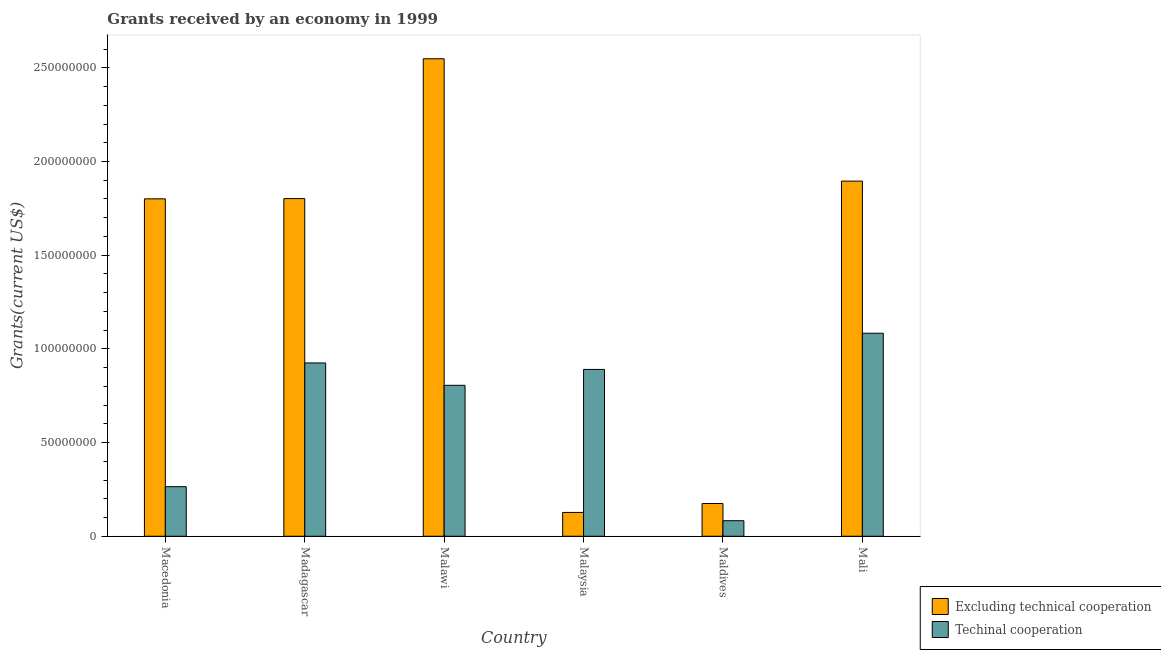How many groups of bars are there?
Your response must be concise. 6. Are the number of bars on each tick of the X-axis equal?
Your response must be concise. Yes. How many bars are there on the 6th tick from the left?
Provide a succinct answer. 2. What is the label of the 1st group of bars from the left?
Offer a terse response. Macedonia. In how many cases, is the number of bars for a given country not equal to the number of legend labels?
Provide a short and direct response. 0. What is the amount of grants received(including technical cooperation) in Malaysia?
Ensure brevity in your answer.  8.90e+07. Across all countries, what is the maximum amount of grants received(including technical cooperation)?
Offer a very short reply. 1.08e+08. Across all countries, what is the minimum amount of grants received(including technical cooperation)?
Give a very brief answer. 8.29e+06. In which country was the amount of grants received(excluding technical cooperation) maximum?
Keep it short and to the point. Malawi. In which country was the amount of grants received(excluding technical cooperation) minimum?
Make the answer very short. Malaysia. What is the total amount of grants received(excluding technical cooperation) in the graph?
Offer a very short reply. 8.35e+08. What is the difference between the amount of grants received(excluding technical cooperation) in Macedonia and that in Mali?
Provide a short and direct response. -9.45e+06. What is the difference between the amount of grants received(excluding technical cooperation) in Maldives and the amount of grants received(including technical cooperation) in Madagascar?
Offer a terse response. -7.50e+07. What is the average amount of grants received(excluding technical cooperation) per country?
Keep it short and to the point. 1.39e+08. What is the difference between the amount of grants received(excluding technical cooperation) and amount of grants received(including technical cooperation) in Mali?
Your answer should be very brief. 8.12e+07. What is the ratio of the amount of grants received(excluding technical cooperation) in Malawi to that in Maldives?
Keep it short and to the point. 14.59. Is the amount of grants received(excluding technical cooperation) in Madagascar less than that in Mali?
Your response must be concise. Yes. Is the difference between the amount of grants received(including technical cooperation) in Macedonia and Malawi greater than the difference between the amount of grants received(excluding technical cooperation) in Macedonia and Malawi?
Your answer should be very brief. Yes. What is the difference between the highest and the second highest amount of grants received(including technical cooperation)?
Make the answer very short. 1.59e+07. What is the difference between the highest and the lowest amount of grants received(excluding technical cooperation)?
Provide a short and direct response. 2.42e+08. In how many countries, is the amount of grants received(including technical cooperation) greater than the average amount of grants received(including technical cooperation) taken over all countries?
Give a very brief answer. 4. What does the 2nd bar from the left in Macedonia represents?
Make the answer very short. Techinal cooperation. What does the 1st bar from the right in Maldives represents?
Your answer should be compact. Techinal cooperation. How many bars are there?
Offer a very short reply. 12. What is the difference between two consecutive major ticks on the Y-axis?
Make the answer very short. 5.00e+07. Are the values on the major ticks of Y-axis written in scientific E-notation?
Keep it short and to the point. No. Where does the legend appear in the graph?
Offer a terse response. Bottom right. How many legend labels are there?
Make the answer very short. 2. How are the legend labels stacked?
Provide a succinct answer. Vertical. What is the title of the graph?
Offer a very short reply. Grants received by an economy in 1999. What is the label or title of the X-axis?
Make the answer very short. Country. What is the label or title of the Y-axis?
Your answer should be compact. Grants(current US$). What is the Grants(current US$) in Excluding technical cooperation in Macedonia?
Give a very brief answer. 1.80e+08. What is the Grants(current US$) of Techinal cooperation in Macedonia?
Provide a short and direct response. 2.64e+07. What is the Grants(current US$) of Excluding technical cooperation in Madagascar?
Make the answer very short. 1.80e+08. What is the Grants(current US$) in Techinal cooperation in Madagascar?
Provide a succinct answer. 9.25e+07. What is the Grants(current US$) of Excluding technical cooperation in Malawi?
Your response must be concise. 2.55e+08. What is the Grants(current US$) of Techinal cooperation in Malawi?
Offer a terse response. 8.06e+07. What is the Grants(current US$) in Excluding technical cooperation in Malaysia?
Your answer should be very brief. 1.27e+07. What is the Grants(current US$) in Techinal cooperation in Malaysia?
Provide a short and direct response. 8.90e+07. What is the Grants(current US$) of Excluding technical cooperation in Maldives?
Your response must be concise. 1.75e+07. What is the Grants(current US$) in Techinal cooperation in Maldives?
Your answer should be very brief. 8.29e+06. What is the Grants(current US$) in Excluding technical cooperation in Mali?
Keep it short and to the point. 1.90e+08. What is the Grants(current US$) in Techinal cooperation in Mali?
Offer a terse response. 1.08e+08. Across all countries, what is the maximum Grants(current US$) in Excluding technical cooperation?
Give a very brief answer. 2.55e+08. Across all countries, what is the maximum Grants(current US$) of Techinal cooperation?
Provide a short and direct response. 1.08e+08. Across all countries, what is the minimum Grants(current US$) of Excluding technical cooperation?
Offer a terse response. 1.27e+07. Across all countries, what is the minimum Grants(current US$) of Techinal cooperation?
Your answer should be compact. 8.29e+06. What is the total Grants(current US$) in Excluding technical cooperation in the graph?
Your response must be concise. 8.35e+08. What is the total Grants(current US$) in Techinal cooperation in the graph?
Ensure brevity in your answer.  4.05e+08. What is the difference between the Grants(current US$) in Excluding technical cooperation in Macedonia and that in Madagascar?
Offer a very short reply. -1.20e+05. What is the difference between the Grants(current US$) of Techinal cooperation in Macedonia and that in Madagascar?
Provide a short and direct response. -6.60e+07. What is the difference between the Grants(current US$) of Excluding technical cooperation in Macedonia and that in Malawi?
Provide a short and direct response. -7.48e+07. What is the difference between the Grants(current US$) of Techinal cooperation in Macedonia and that in Malawi?
Your answer should be very brief. -5.41e+07. What is the difference between the Grants(current US$) of Excluding technical cooperation in Macedonia and that in Malaysia?
Provide a succinct answer. 1.67e+08. What is the difference between the Grants(current US$) in Techinal cooperation in Macedonia and that in Malaysia?
Give a very brief answer. -6.26e+07. What is the difference between the Grants(current US$) of Excluding technical cooperation in Macedonia and that in Maldives?
Your response must be concise. 1.63e+08. What is the difference between the Grants(current US$) of Techinal cooperation in Macedonia and that in Maldives?
Your answer should be very brief. 1.82e+07. What is the difference between the Grants(current US$) in Excluding technical cooperation in Macedonia and that in Mali?
Ensure brevity in your answer.  -9.45e+06. What is the difference between the Grants(current US$) of Techinal cooperation in Macedonia and that in Mali?
Give a very brief answer. -8.19e+07. What is the difference between the Grants(current US$) in Excluding technical cooperation in Madagascar and that in Malawi?
Make the answer very short. -7.46e+07. What is the difference between the Grants(current US$) of Techinal cooperation in Madagascar and that in Malawi?
Your answer should be compact. 1.19e+07. What is the difference between the Grants(current US$) of Excluding technical cooperation in Madagascar and that in Malaysia?
Offer a terse response. 1.67e+08. What is the difference between the Grants(current US$) of Techinal cooperation in Madagascar and that in Malaysia?
Give a very brief answer. 3.46e+06. What is the difference between the Grants(current US$) of Excluding technical cooperation in Madagascar and that in Maldives?
Offer a very short reply. 1.63e+08. What is the difference between the Grants(current US$) of Techinal cooperation in Madagascar and that in Maldives?
Make the answer very short. 8.42e+07. What is the difference between the Grants(current US$) in Excluding technical cooperation in Madagascar and that in Mali?
Your answer should be very brief. -9.33e+06. What is the difference between the Grants(current US$) in Techinal cooperation in Madagascar and that in Mali?
Your response must be concise. -1.59e+07. What is the difference between the Grants(current US$) of Excluding technical cooperation in Malawi and that in Malaysia?
Your answer should be compact. 2.42e+08. What is the difference between the Grants(current US$) of Techinal cooperation in Malawi and that in Malaysia?
Provide a succinct answer. -8.47e+06. What is the difference between the Grants(current US$) of Excluding technical cooperation in Malawi and that in Maldives?
Make the answer very short. 2.37e+08. What is the difference between the Grants(current US$) of Techinal cooperation in Malawi and that in Maldives?
Offer a very short reply. 7.23e+07. What is the difference between the Grants(current US$) of Excluding technical cooperation in Malawi and that in Mali?
Offer a very short reply. 6.53e+07. What is the difference between the Grants(current US$) in Techinal cooperation in Malawi and that in Mali?
Offer a very short reply. -2.78e+07. What is the difference between the Grants(current US$) of Excluding technical cooperation in Malaysia and that in Maldives?
Your answer should be very brief. -4.76e+06. What is the difference between the Grants(current US$) in Techinal cooperation in Malaysia and that in Maldives?
Keep it short and to the point. 8.07e+07. What is the difference between the Grants(current US$) in Excluding technical cooperation in Malaysia and that in Mali?
Keep it short and to the point. -1.77e+08. What is the difference between the Grants(current US$) of Techinal cooperation in Malaysia and that in Mali?
Ensure brevity in your answer.  -1.93e+07. What is the difference between the Grants(current US$) of Excluding technical cooperation in Maldives and that in Mali?
Provide a short and direct response. -1.72e+08. What is the difference between the Grants(current US$) in Techinal cooperation in Maldives and that in Mali?
Offer a terse response. -1.00e+08. What is the difference between the Grants(current US$) in Excluding technical cooperation in Macedonia and the Grants(current US$) in Techinal cooperation in Madagascar?
Your answer should be very brief. 8.76e+07. What is the difference between the Grants(current US$) of Excluding technical cooperation in Macedonia and the Grants(current US$) of Techinal cooperation in Malawi?
Offer a terse response. 9.95e+07. What is the difference between the Grants(current US$) in Excluding technical cooperation in Macedonia and the Grants(current US$) in Techinal cooperation in Malaysia?
Keep it short and to the point. 9.10e+07. What is the difference between the Grants(current US$) of Excluding technical cooperation in Macedonia and the Grants(current US$) of Techinal cooperation in Maldives?
Provide a short and direct response. 1.72e+08. What is the difference between the Grants(current US$) in Excluding technical cooperation in Macedonia and the Grants(current US$) in Techinal cooperation in Mali?
Offer a very short reply. 7.17e+07. What is the difference between the Grants(current US$) of Excluding technical cooperation in Madagascar and the Grants(current US$) of Techinal cooperation in Malawi?
Make the answer very short. 9.96e+07. What is the difference between the Grants(current US$) of Excluding technical cooperation in Madagascar and the Grants(current US$) of Techinal cooperation in Malaysia?
Provide a succinct answer. 9.12e+07. What is the difference between the Grants(current US$) in Excluding technical cooperation in Madagascar and the Grants(current US$) in Techinal cooperation in Maldives?
Your answer should be very brief. 1.72e+08. What is the difference between the Grants(current US$) of Excluding technical cooperation in Madagascar and the Grants(current US$) of Techinal cooperation in Mali?
Give a very brief answer. 7.18e+07. What is the difference between the Grants(current US$) of Excluding technical cooperation in Malawi and the Grants(current US$) of Techinal cooperation in Malaysia?
Offer a terse response. 1.66e+08. What is the difference between the Grants(current US$) of Excluding technical cooperation in Malawi and the Grants(current US$) of Techinal cooperation in Maldives?
Ensure brevity in your answer.  2.47e+08. What is the difference between the Grants(current US$) of Excluding technical cooperation in Malawi and the Grants(current US$) of Techinal cooperation in Mali?
Ensure brevity in your answer.  1.46e+08. What is the difference between the Grants(current US$) in Excluding technical cooperation in Malaysia and the Grants(current US$) in Techinal cooperation in Maldives?
Provide a short and direct response. 4.42e+06. What is the difference between the Grants(current US$) in Excluding technical cooperation in Malaysia and the Grants(current US$) in Techinal cooperation in Mali?
Give a very brief answer. -9.56e+07. What is the difference between the Grants(current US$) of Excluding technical cooperation in Maldives and the Grants(current US$) of Techinal cooperation in Mali?
Make the answer very short. -9.09e+07. What is the average Grants(current US$) in Excluding technical cooperation per country?
Your answer should be very brief. 1.39e+08. What is the average Grants(current US$) of Techinal cooperation per country?
Provide a succinct answer. 6.75e+07. What is the difference between the Grants(current US$) of Excluding technical cooperation and Grants(current US$) of Techinal cooperation in Macedonia?
Give a very brief answer. 1.54e+08. What is the difference between the Grants(current US$) of Excluding technical cooperation and Grants(current US$) of Techinal cooperation in Madagascar?
Ensure brevity in your answer.  8.77e+07. What is the difference between the Grants(current US$) of Excluding technical cooperation and Grants(current US$) of Techinal cooperation in Malawi?
Your response must be concise. 1.74e+08. What is the difference between the Grants(current US$) of Excluding technical cooperation and Grants(current US$) of Techinal cooperation in Malaysia?
Your answer should be compact. -7.63e+07. What is the difference between the Grants(current US$) in Excluding technical cooperation and Grants(current US$) in Techinal cooperation in Maldives?
Provide a short and direct response. 9.18e+06. What is the difference between the Grants(current US$) of Excluding technical cooperation and Grants(current US$) of Techinal cooperation in Mali?
Provide a short and direct response. 8.12e+07. What is the ratio of the Grants(current US$) in Techinal cooperation in Macedonia to that in Madagascar?
Provide a succinct answer. 0.29. What is the ratio of the Grants(current US$) of Excluding technical cooperation in Macedonia to that in Malawi?
Offer a terse response. 0.71. What is the ratio of the Grants(current US$) in Techinal cooperation in Macedonia to that in Malawi?
Give a very brief answer. 0.33. What is the ratio of the Grants(current US$) in Excluding technical cooperation in Macedonia to that in Malaysia?
Keep it short and to the point. 14.17. What is the ratio of the Grants(current US$) of Techinal cooperation in Macedonia to that in Malaysia?
Make the answer very short. 0.3. What is the ratio of the Grants(current US$) of Excluding technical cooperation in Macedonia to that in Maldives?
Offer a very short reply. 10.31. What is the ratio of the Grants(current US$) of Techinal cooperation in Macedonia to that in Maldives?
Ensure brevity in your answer.  3.19. What is the ratio of the Grants(current US$) of Excluding technical cooperation in Macedonia to that in Mali?
Offer a terse response. 0.95. What is the ratio of the Grants(current US$) of Techinal cooperation in Macedonia to that in Mali?
Ensure brevity in your answer.  0.24. What is the ratio of the Grants(current US$) of Excluding technical cooperation in Madagascar to that in Malawi?
Keep it short and to the point. 0.71. What is the ratio of the Grants(current US$) in Techinal cooperation in Madagascar to that in Malawi?
Give a very brief answer. 1.15. What is the ratio of the Grants(current US$) of Excluding technical cooperation in Madagascar to that in Malaysia?
Offer a very short reply. 14.18. What is the ratio of the Grants(current US$) in Techinal cooperation in Madagascar to that in Malaysia?
Your answer should be very brief. 1.04. What is the ratio of the Grants(current US$) of Excluding technical cooperation in Madagascar to that in Maldives?
Keep it short and to the point. 10.31. What is the ratio of the Grants(current US$) of Techinal cooperation in Madagascar to that in Maldives?
Ensure brevity in your answer.  11.16. What is the ratio of the Grants(current US$) of Excluding technical cooperation in Madagascar to that in Mali?
Provide a succinct answer. 0.95. What is the ratio of the Grants(current US$) in Techinal cooperation in Madagascar to that in Mali?
Offer a very short reply. 0.85. What is the ratio of the Grants(current US$) in Excluding technical cooperation in Malawi to that in Malaysia?
Provide a short and direct response. 20.05. What is the ratio of the Grants(current US$) of Techinal cooperation in Malawi to that in Malaysia?
Ensure brevity in your answer.  0.9. What is the ratio of the Grants(current US$) in Excluding technical cooperation in Malawi to that in Maldives?
Ensure brevity in your answer.  14.59. What is the ratio of the Grants(current US$) in Techinal cooperation in Malawi to that in Maldives?
Offer a very short reply. 9.72. What is the ratio of the Grants(current US$) in Excluding technical cooperation in Malawi to that in Mali?
Give a very brief answer. 1.34. What is the ratio of the Grants(current US$) in Techinal cooperation in Malawi to that in Mali?
Ensure brevity in your answer.  0.74. What is the ratio of the Grants(current US$) of Excluding technical cooperation in Malaysia to that in Maldives?
Make the answer very short. 0.73. What is the ratio of the Grants(current US$) in Techinal cooperation in Malaysia to that in Maldives?
Keep it short and to the point. 10.74. What is the ratio of the Grants(current US$) of Excluding technical cooperation in Malaysia to that in Mali?
Your answer should be very brief. 0.07. What is the ratio of the Grants(current US$) in Techinal cooperation in Malaysia to that in Mali?
Your answer should be very brief. 0.82. What is the ratio of the Grants(current US$) of Excluding technical cooperation in Maldives to that in Mali?
Your answer should be very brief. 0.09. What is the ratio of the Grants(current US$) of Techinal cooperation in Maldives to that in Mali?
Ensure brevity in your answer.  0.08. What is the difference between the highest and the second highest Grants(current US$) in Excluding technical cooperation?
Your answer should be compact. 6.53e+07. What is the difference between the highest and the second highest Grants(current US$) in Techinal cooperation?
Offer a very short reply. 1.59e+07. What is the difference between the highest and the lowest Grants(current US$) in Excluding technical cooperation?
Give a very brief answer. 2.42e+08. What is the difference between the highest and the lowest Grants(current US$) of Techinal cooperation?
Ensure brevity in your answer.  1.00e+08. 